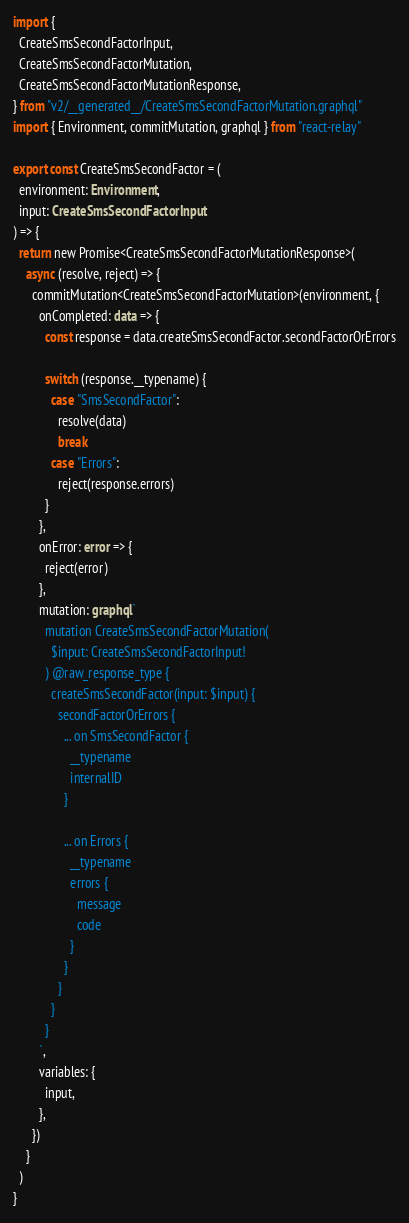Convert code to text. <code><loc_0><loc_0><loc_500><loc_500><_TypeScript_>import {
  CreateSmsSecondFactorInput,
  CreateSmsSecondFactorMutation,
  CreateSmsSecondFactorMutationResponse,
} from "v2/__generated__/CreateSmsSecondFactorMutation.graphql"
import { Environment, commitMutation, graphql } from "react-relay"

export const CreateSmsSecondFactor = (
  environment: Environment,
  input: CreateSmsSecondFactorInput
) => {
  return new Promise<CreateSmsSecondFactorMutationResponse>(
    async (resolve, reject) => {
      commitMutation<CreateSmsSecondFactorMutation>(environment, {
        onCompleted: data => {
          const response = data.createSmsSecondFactor.secondFactorOrErrors

          switch (response.__typename) {
            case "SmsSecondFactor":
              resolve(data)
              break
            case "Errors":
              reject(response.errors)
          }
        },
        onError: error => {
          reject(error)
        },
        mutation: graphql`
          mutation CreateSmsSecondFactorMutation(
            $input: CreateSmsSecondFactorInput!
          ) @raw_response_type {
            createSmsSecondFactor(input: $input) {
              secondFactorOrErrors {
                ... on SmsSecondFactor {
                  __typename
                  internalID
                }

                ... on Errors {
                  __typename
                  errors {
                    message
                    code
                  }
                }
              }
            }
          }
        `,
        variables: {
          input,
        },
      })
    }
  )
}
</code> 